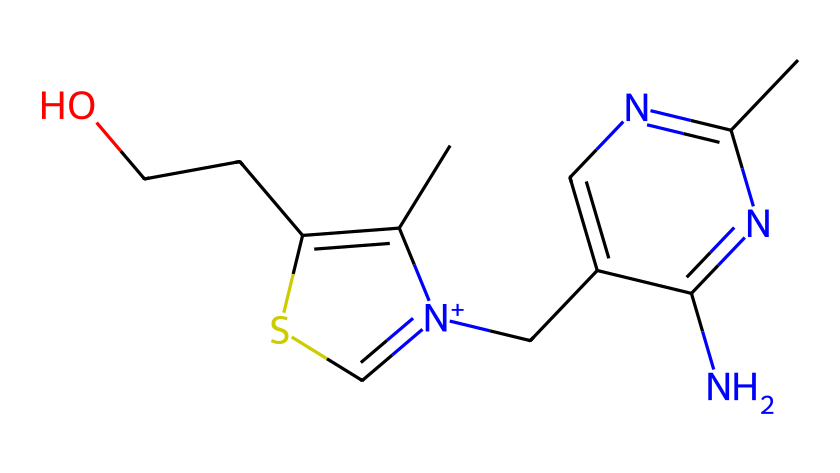How many sulfur atoms are in this structure? By inspecting the SMILES representation, we can see the letter "S" indicates sulfur atoms. Counting the occurrences of "S" in the SMILES shows there is one sulfur atom present.
Answer: 1 What type of bond connects the sulfur to the nitrogen in the structure? In the SMILES, the bond connecting sulfur to nitrogen "SC=[N+]" indicates a double bond due to the "=" sign. This means sulfur forms a double bond with nitrogen.
Answer: double bond What is the chemical name of this compound? The compound represented by the SMILES is known as thiamine (vitamin B1). This knowledge stems from recognizing the specific structure and groups associated with thiamine.
Answer: thiamine How many nitrogen atoms are present in this chemical? The "N" symbols in the SMILES represent nitrogen atoms. Counting the "N" symbols indicates there are four nitrogen atoms in the structure.
Answer: 4 Which functional group in the chemical indicates it is a sulfur compound? The presence of the sulfur atom ("S") in the structure signifies that this compound is a sulfur compound. The specific functional group here is a thiazole ring where sulfur is part of the heterocyclic structure.
Answer: thiazole What is the oxidation state of sulfur in this compound? In thiamine's structure, sulfur is connected to carbon and nitrogen through a double bond and a single bond, respectively. By common oxidation state rules, this suggests sulfur is in the +2 oxidation state.
Answer: +2 What role does thiamine play in preventing alcohol-related neurological disorders? Thiamine is crucial for carbohydrate metabolism and nerve function. Alcohol abuse can lead to thiamine deficiency, increasing the risk of neurological disorders.
Answer: essential in metabolism 